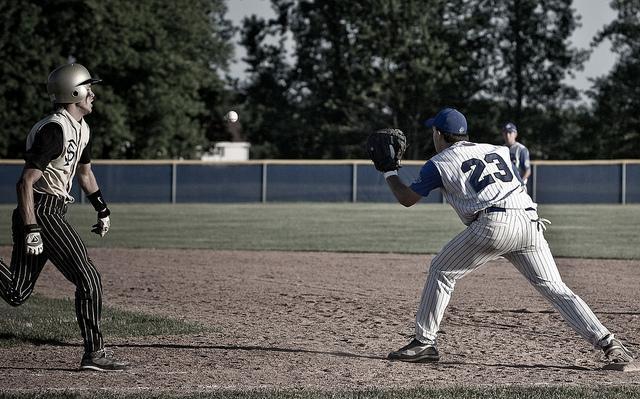How many people are there?
Give a very brief answer. 2. 